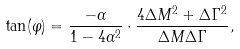<formula> <loc_0><loc_0><loc_500><loc_500>\tan ( \varphi ) = \frac { - \alpha } { 1 - 4 \alpha ^ { 2 } } \cdot \frac { 4 \Delta M ^ { 2 } + \Delta \Gamma ^ { 2 } } { \Delta M \Delta \Gamma } ,</formula> 